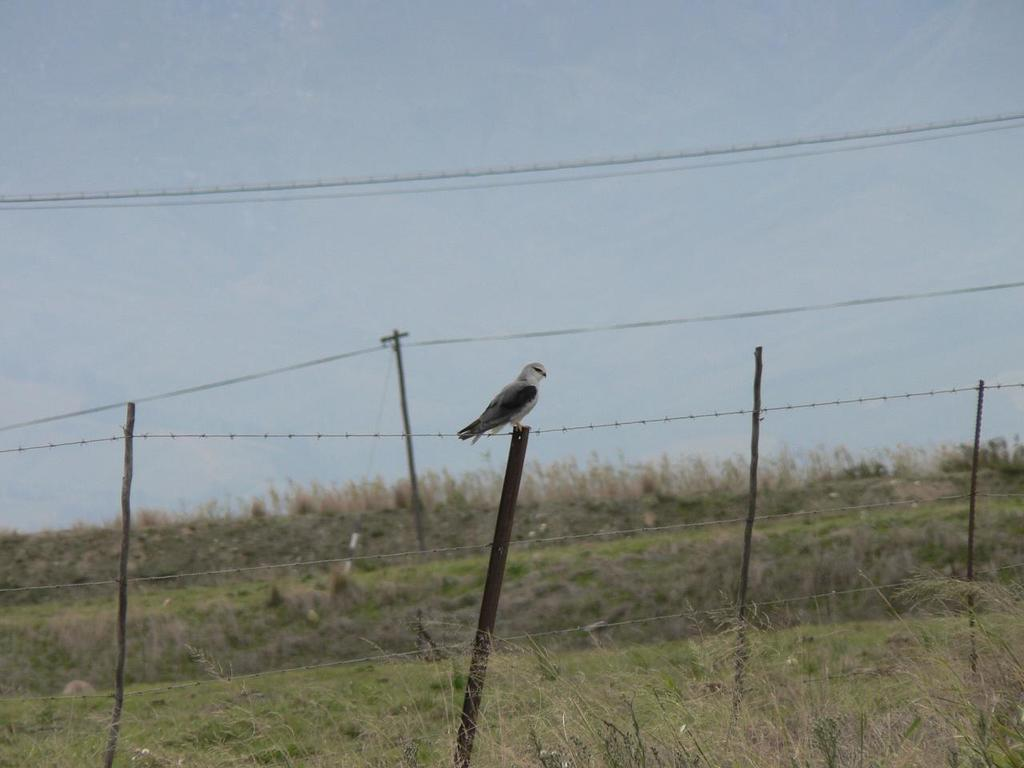What is on top of the pole in the image? There is a bird on a pole in the image. How many poles can be seen in the image? There are poles in the image. What else is present in the image besides the poles? There are wires in the image. What type of natural environment is visible in the image? The ground with grass is visible in the image. What is visible above the poles and wires in the image? The sky is visible in the image. What advice does the bird's father give to the bird in the image? There is no indication in the image that the bird has a father or that any advice is being given. 